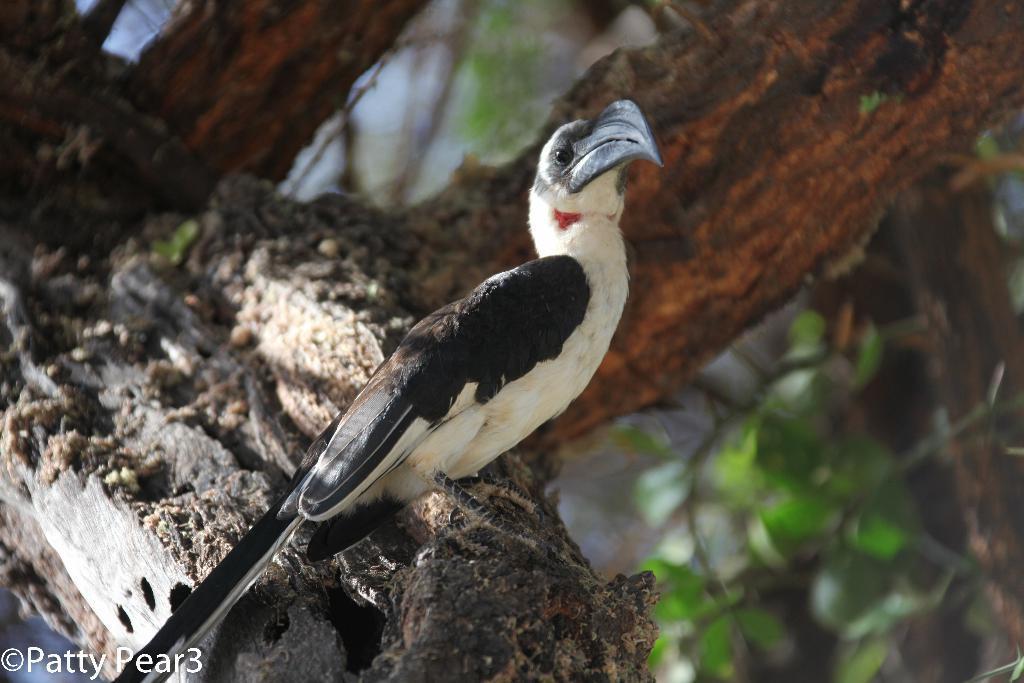Can you describe this image briefly? As we can see in the image there is a bird who is standing on a tree stem. The bird is in black and white feathers and the beak of the bird is in black colour. Behind the bird there are tree stems. 